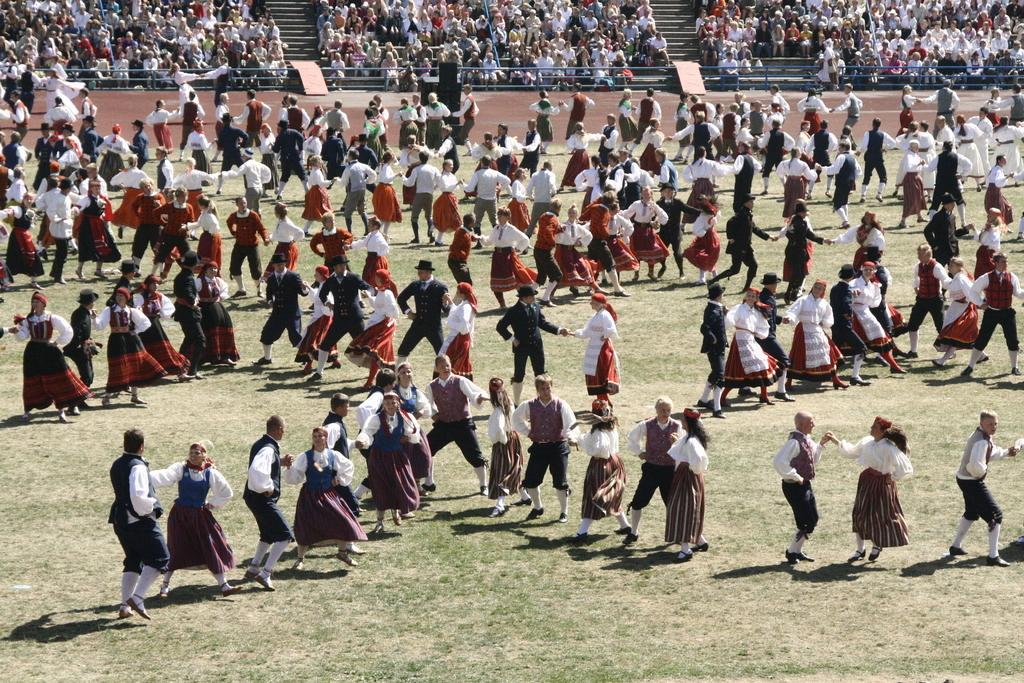What are the people in the image doing? The people in the image are dancing. Can you describe the setting of the image? There is an audience in the background of the image. What type of voice can be heard coming from the dolls in the image? There are no dolls present in the image, so it's not possible to determine what, if any, voices might be heard. 